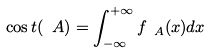<formula> <loc_0><loc_0><loc_500><loc_500>\cos t ( \ A ) = \int _ { - \infty } ^ { + \infty } f _ { \ A } ( x ) d x</formula> 